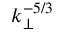Convert formula to latex. <formula><loc_0><loc_0><loc_500><loc_500>k _ { \perp } ^ { - 5 / 3 }</formula> 